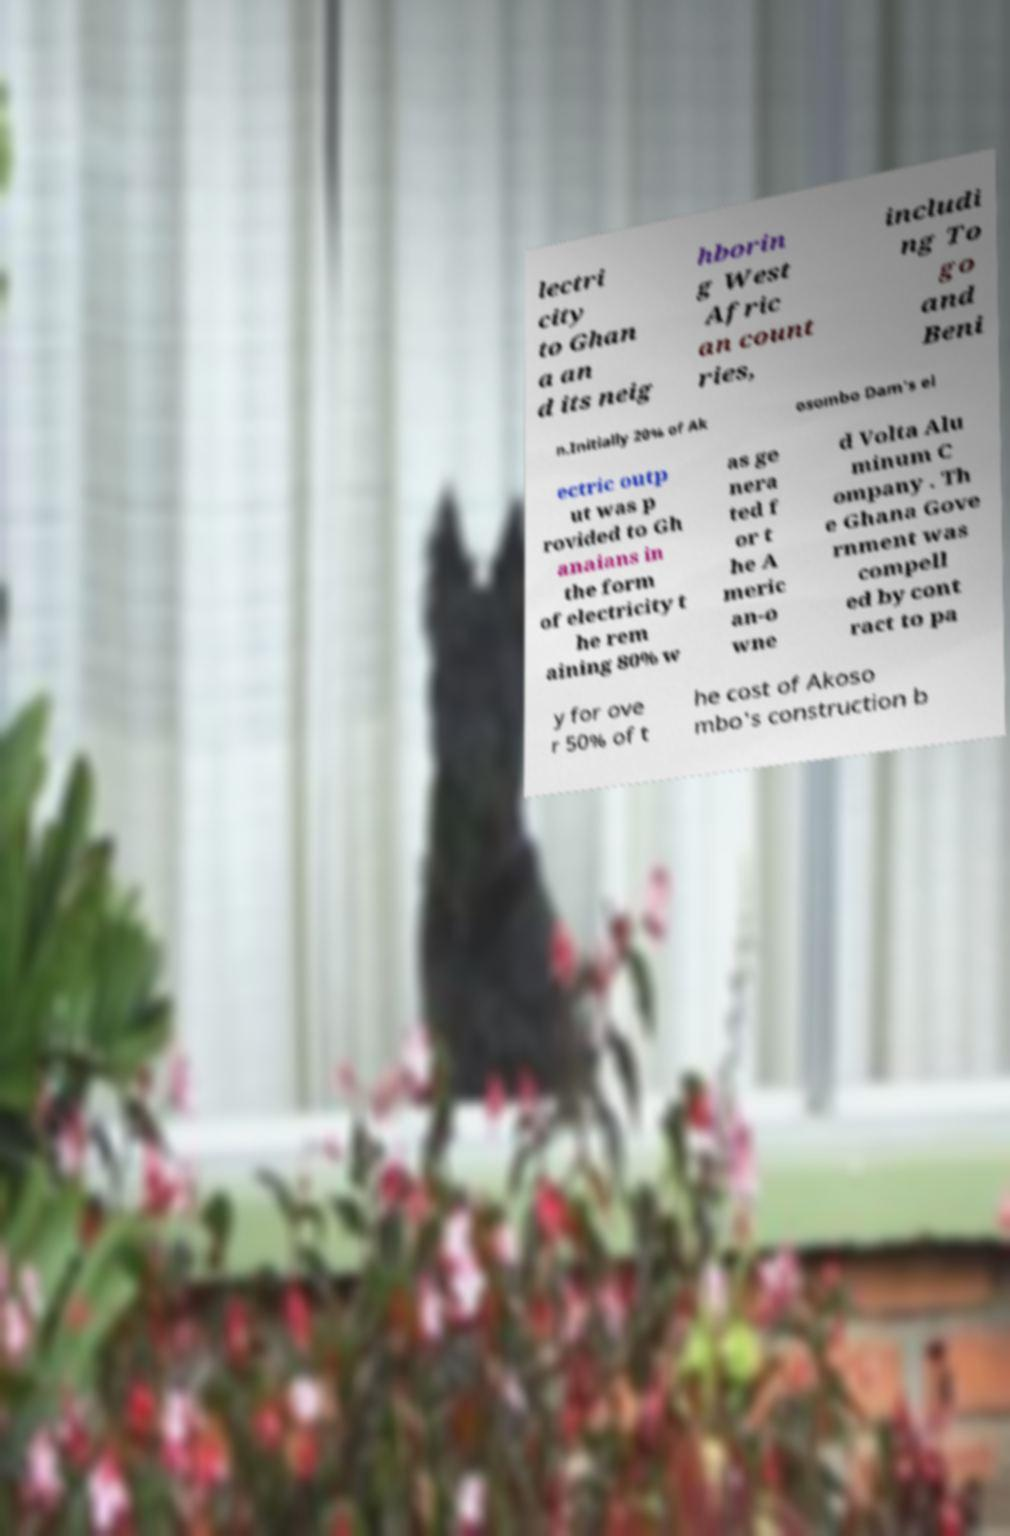Please identify and transcribe the text found in this image. lectri city to Ghan a an d its neig hborin g West Afric an count ries, includi ng To go and Beni n.Initially 20% of Ak osombo Dam's el ectric outp ut was p rovided to Gh anaians in the form of electricity t he rem aining 80% w as ge nera ted f or t he A meric an-o wne d Volta Alu minum C ompany . Th e Ghana Gove rnment was compell ed by cont ract to pa y for ove r 50% of t he cost of Akoso mbo's construction b 